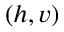<formula> <loc_0><loc_0><loc_500><loc_500>( h , v )</formula> 